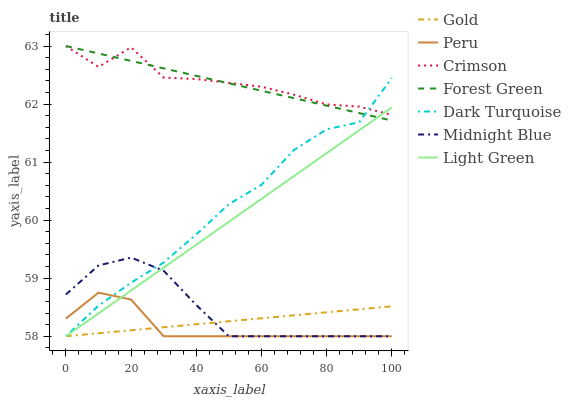Does Peru have the minimum area under the curve?
Answer yes or no. Yes. Does Crimson have the maximum area under the curve?
Answer yes or no. Yes. Does Gold have the minimum area under the curve?
Answer yes or no. No. Does Gold have the maximum area under the curve?
Answer yes or no. No. Is Forest Green the smoothest?
Answer yes or no. Yes. Is Crimson the roughest?
Answer yes or no. Yes. Is Gold the smoothest?
Answer yes or no. No. Is Gold the roughest?
Answer yes or no. No. Does Midnight Blue have the lowest value?
Answer yes or no. Yes. Does Forest Green have the lowest value?
Answer yes or no. No. Does Crimson have the highest value?
Answer yes or no. Yes. Does Dark Turquoise have the highest value?
Answer yes or no. No. Is Midnight Blue less than Forest Green?
Answer yes or no. Yes. Is Crimson greater than Peru?
Answer yes or no. Yes. Does Light Green intersect Crimson?
Answer yes or no. Yes. Is Light Green less than Crimson?
Answer yes or no. No. Is Light Green greater than Crimson?
Answer yes or no. No. Does Midnight Blue intersect Forest Green?
Answer yes or no. No. 